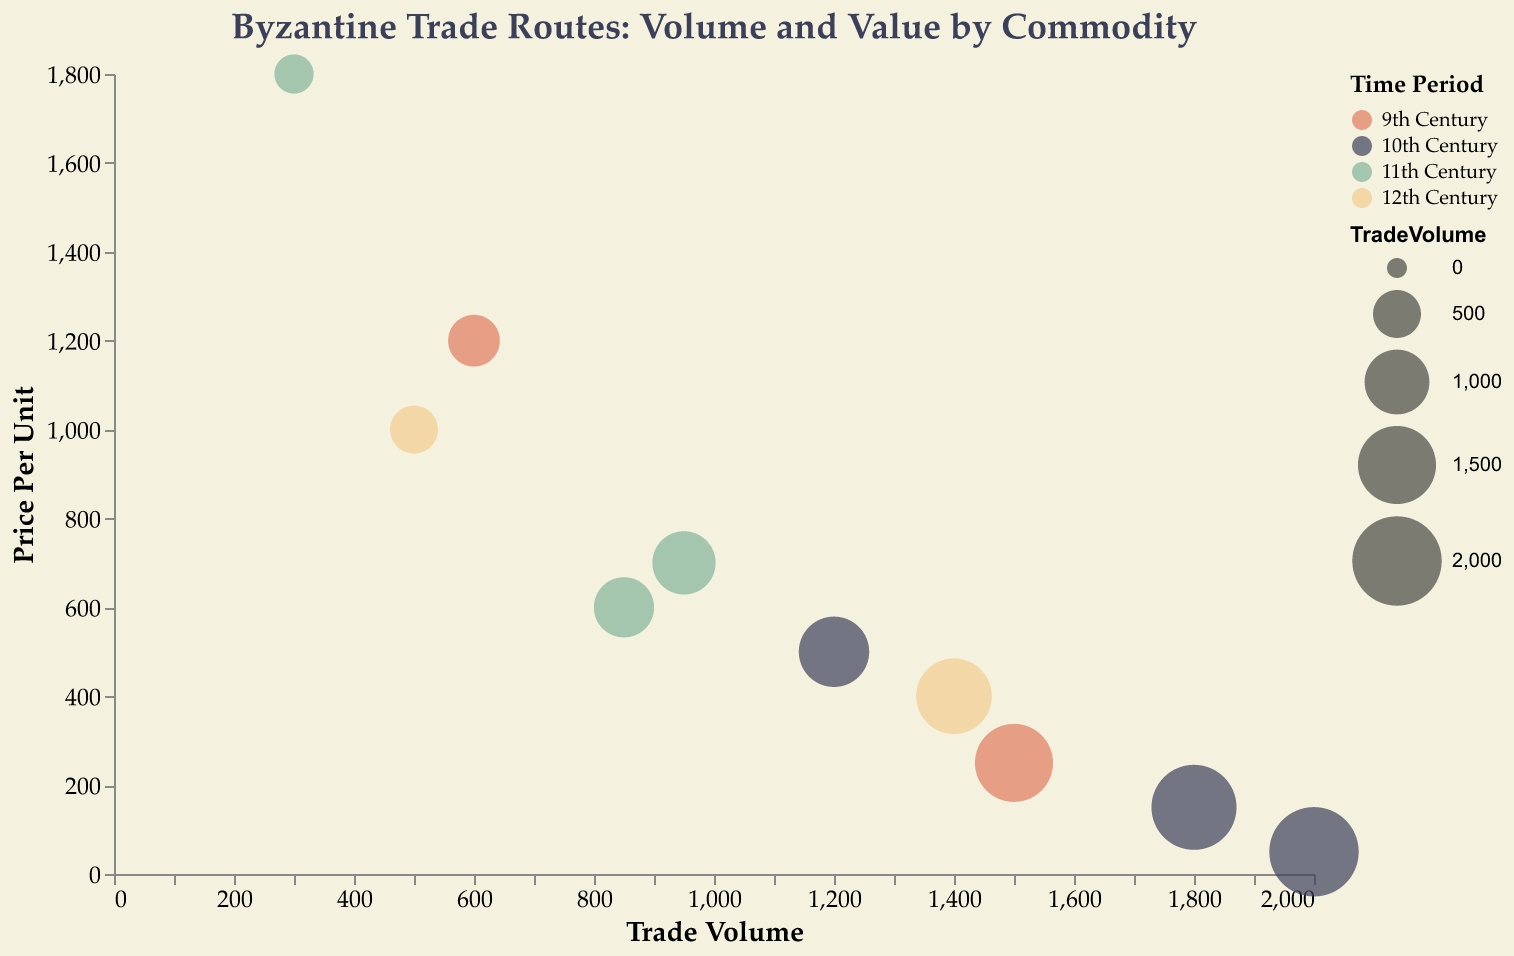How many trade routes are depicted in the figure? Count the number of unique trade routes listed in the plot.
Answer: 10 Which commodity has the highest trade volume? Look for the bubble with the largest size (representing trade volume) and identify the associated commodity. The largest bubble corresponds to "Timber."
Answer: Timber What is the trade volume of Silk traded between Constantinople and Venice? Hover over or identify the bubble corresponding to Silk in the tooltip for the trade route "Constantinople-Venice."
Answer: 1200 Which century has the most trade routes according to the color legend? Observe the colors representing each century in the legend and count how many bubbles correspond to each color. The 11th Century (green) seems to have the most bubbles.
Answer: 11th Century What is the difference in price per unit between Gold and Oil? Find the bubbles representing Gold and Oil and their respective price per unit from the tooltip. Subtract the price per unit of Oil from the price per unit of Gold.
Answer: 1550 Which trade route results in the highest value of goods traded (Trade Volume * Price Per Unit)? Calculate Trade Volume * Price Per Unit for each trade route and identify the highest value. Gold's route is Constantinople-Barcelona with a calculated value of 300 * 1800 = 540,000.
Answer: Constantinople-Barcelona Which two commodities have the closest price per unit among the listed commodities? Compare the price per unit values from the tooltip for all commodities and find the two closest values. "Silk" and "Porcelain" are closest with prices of 500 and 1000, respectively.
Answer: Silk, Porcelain What is the average trade volume of commodities traded in the 12th Century? Identify the commodities from the 12th Century and calculate their average trade volume. (1400 for Textiles and 500 for Porcelain), (1400 + 500) / 2 = 950.
Answer: 950 How does the trade volume of Olive Oil compare to the trade volume of Silk? Identify the trade volumes of Olive Oil and Silk, found in the tooltip for their respective trade routes, and compare them. Olive Oil's trade volume is 1800, while Silk's is 1200. Olive Oil has a higher trade volume.
Answer: Olive Oil has a higher trade volume What trade route has the lowest price per unit commodity? Look for the bubble with the lowest Y-axis value (Price Per Unit) and identify the corresponding trade route. The lowest price per unit is 50 for Timber on the route Thessaloniki-Marseille.
Answer: Thessaloniki-Marseille 